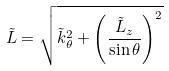<formula> <loc_0><loc_0><loc_500><loc_500>\tilde { L } = \sqrt { \tilde { k } _ { \theta } ^ { 2 } + \left ( \frac { \tilde { L } _ { z } } { \sin \theta } \right ) ^ { 2 } }</formula> 